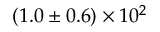Convert formula to latex. <formula><loc_0><loc_0><loc_500><loc_500>( 1 . 0 \pm 0 . 6 ) \times 1 0 ^ { 2 }</formula> 